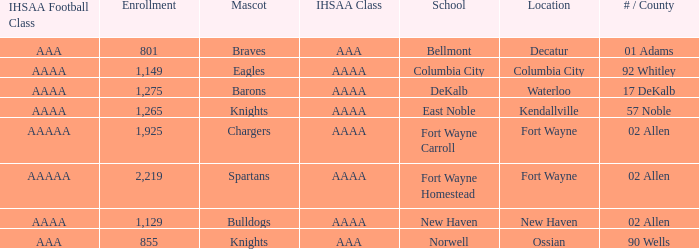What's the enrollment for Kendallville? 1265.0. Write the full table. {'header': ['IHSAA Football Class', 'Enrollment', 'Mascot', 'IHSAA Class', 'School', 'Location', '# / County'], 'rows': [['AAA', '801', 'Braves', 'AAA', 'Bellmont', 'Decatur', '01 Adams'], ['AAAA', '1,149', 'Eagles', 'AAAA', 'Columbia City', 'Columbia City', '92 Whitley'], ['AAAA', '1,275', 'Barons', 'AAAA', 'DeKalb', 'Waterloo', '17 DeKalb'], ['AAAA', '1,265', 'Knights', 'AAAA', 'East Noble', 'Kendallville', '57 Noble'], ['AAAAA', '1,925', 'Chargers', 'AAAA', 'Fort Wayne Carroll', 'Fort Wayne', '02 Allen'], ['AAAAA', '2,219', 'Spartans', 'AAAA', 'Fort Wayne Homestead', 'Fort Wayne', '02 Allen'], ['AAAA', '1,129', 'Bulldogs', 'AAAA', 'New Haven', 'New Haven', '02 Allen'], ['AAA', '855', 'Knights', 'AAA', 'Norwell', 'Ossian', '90 Wells']]} 